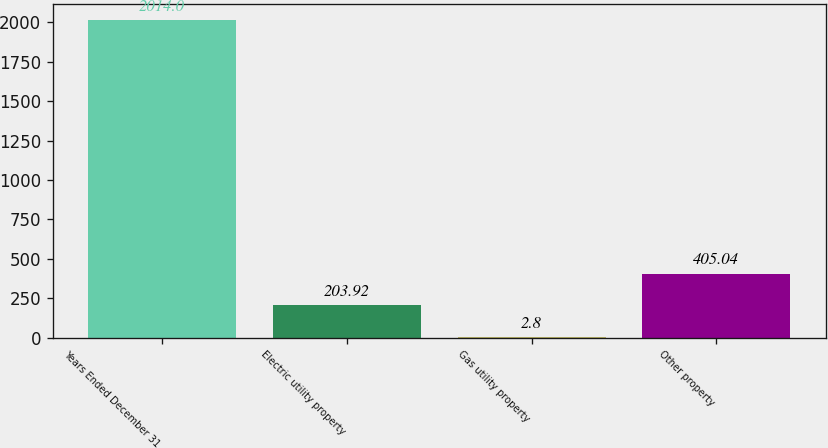<chart> <loc_0><loc_0><loc_500><loc_500><bar_chart><fcel>Years Ended December 31<fcel>Electric utility property<fcel>Gas utility property<fcel>Other property<nl><fcel>2014<fcel>203.92<fcel>2.8<fcel>405.04<nl></chart> 